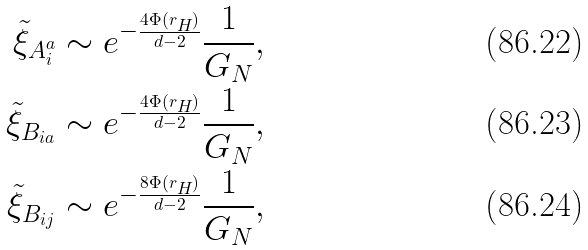<formula> <loc_0><loc_0><loc_500><loc_500>\tilde { \xi } _ { A _ { i } ^ { a } } & \sim e ^ { - \frac { 4 \Phi ( r _ { H } ) } { d - 2 } } \frac { 1 } { G _ { N } } , \\ \tilde { \xi } _ { B _ { i a } } & \sim e ^ { - \frac { 4 \Phi ( r _ { H } ) } { d - 2 } } \frac { 1 } { G _ { N } } , \\ \tilde { \xi } _ { B _ { i j } } & \sim e ^ { - \frac { 8 \Phi ( r _ { H } ) } { d - 2 } } \frac { 1 } { G _ { N } } ,</formula> 